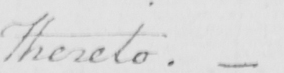Can you read and transcribe this handwriting? Thereto  .  _ 